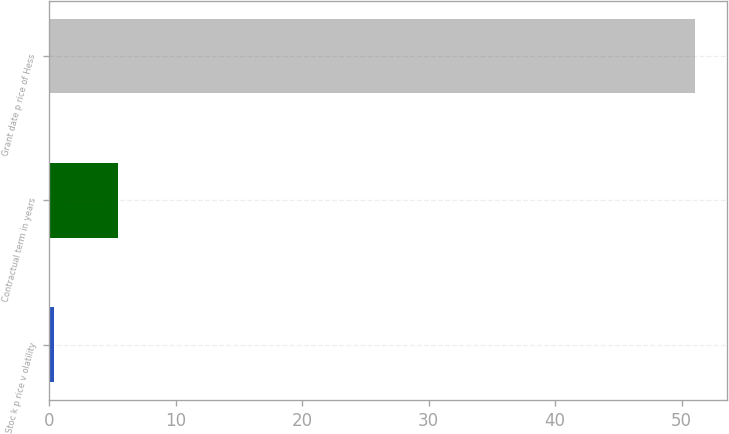Convert chart. <chart><loc_0><loc_0><loc_500><loc_500><bar_chart><fcel>Stoc k p rice v olatility<fcel>Contractual term in years<fcel>Grant date p rice of Hess<nl><fcel>0.39<fcel>5.45<fcel>51.03<nl></chart> 